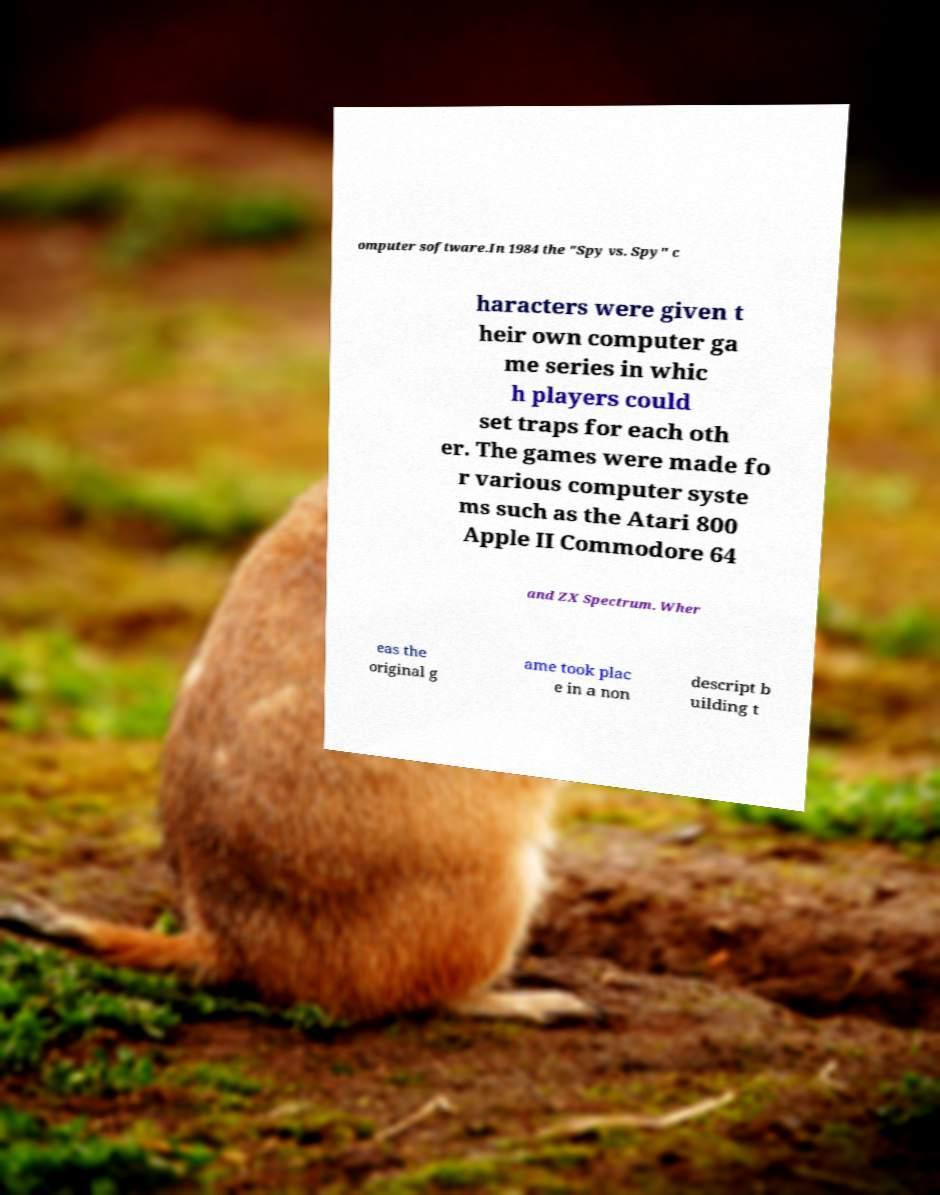I need the written content from this picture converted into text. Can you do that? omputer software.In 1984 the "Spy vs. Spy" c haracters were given t heir own computer ga me series in whic h players could set traps for each oth er. The games were made fo r various computer syste ms such as the Atari 800 Apple II Commodore 64 and ZX Spectrum. Wher eas the original g ame took plac e in a non descript b uilding t 